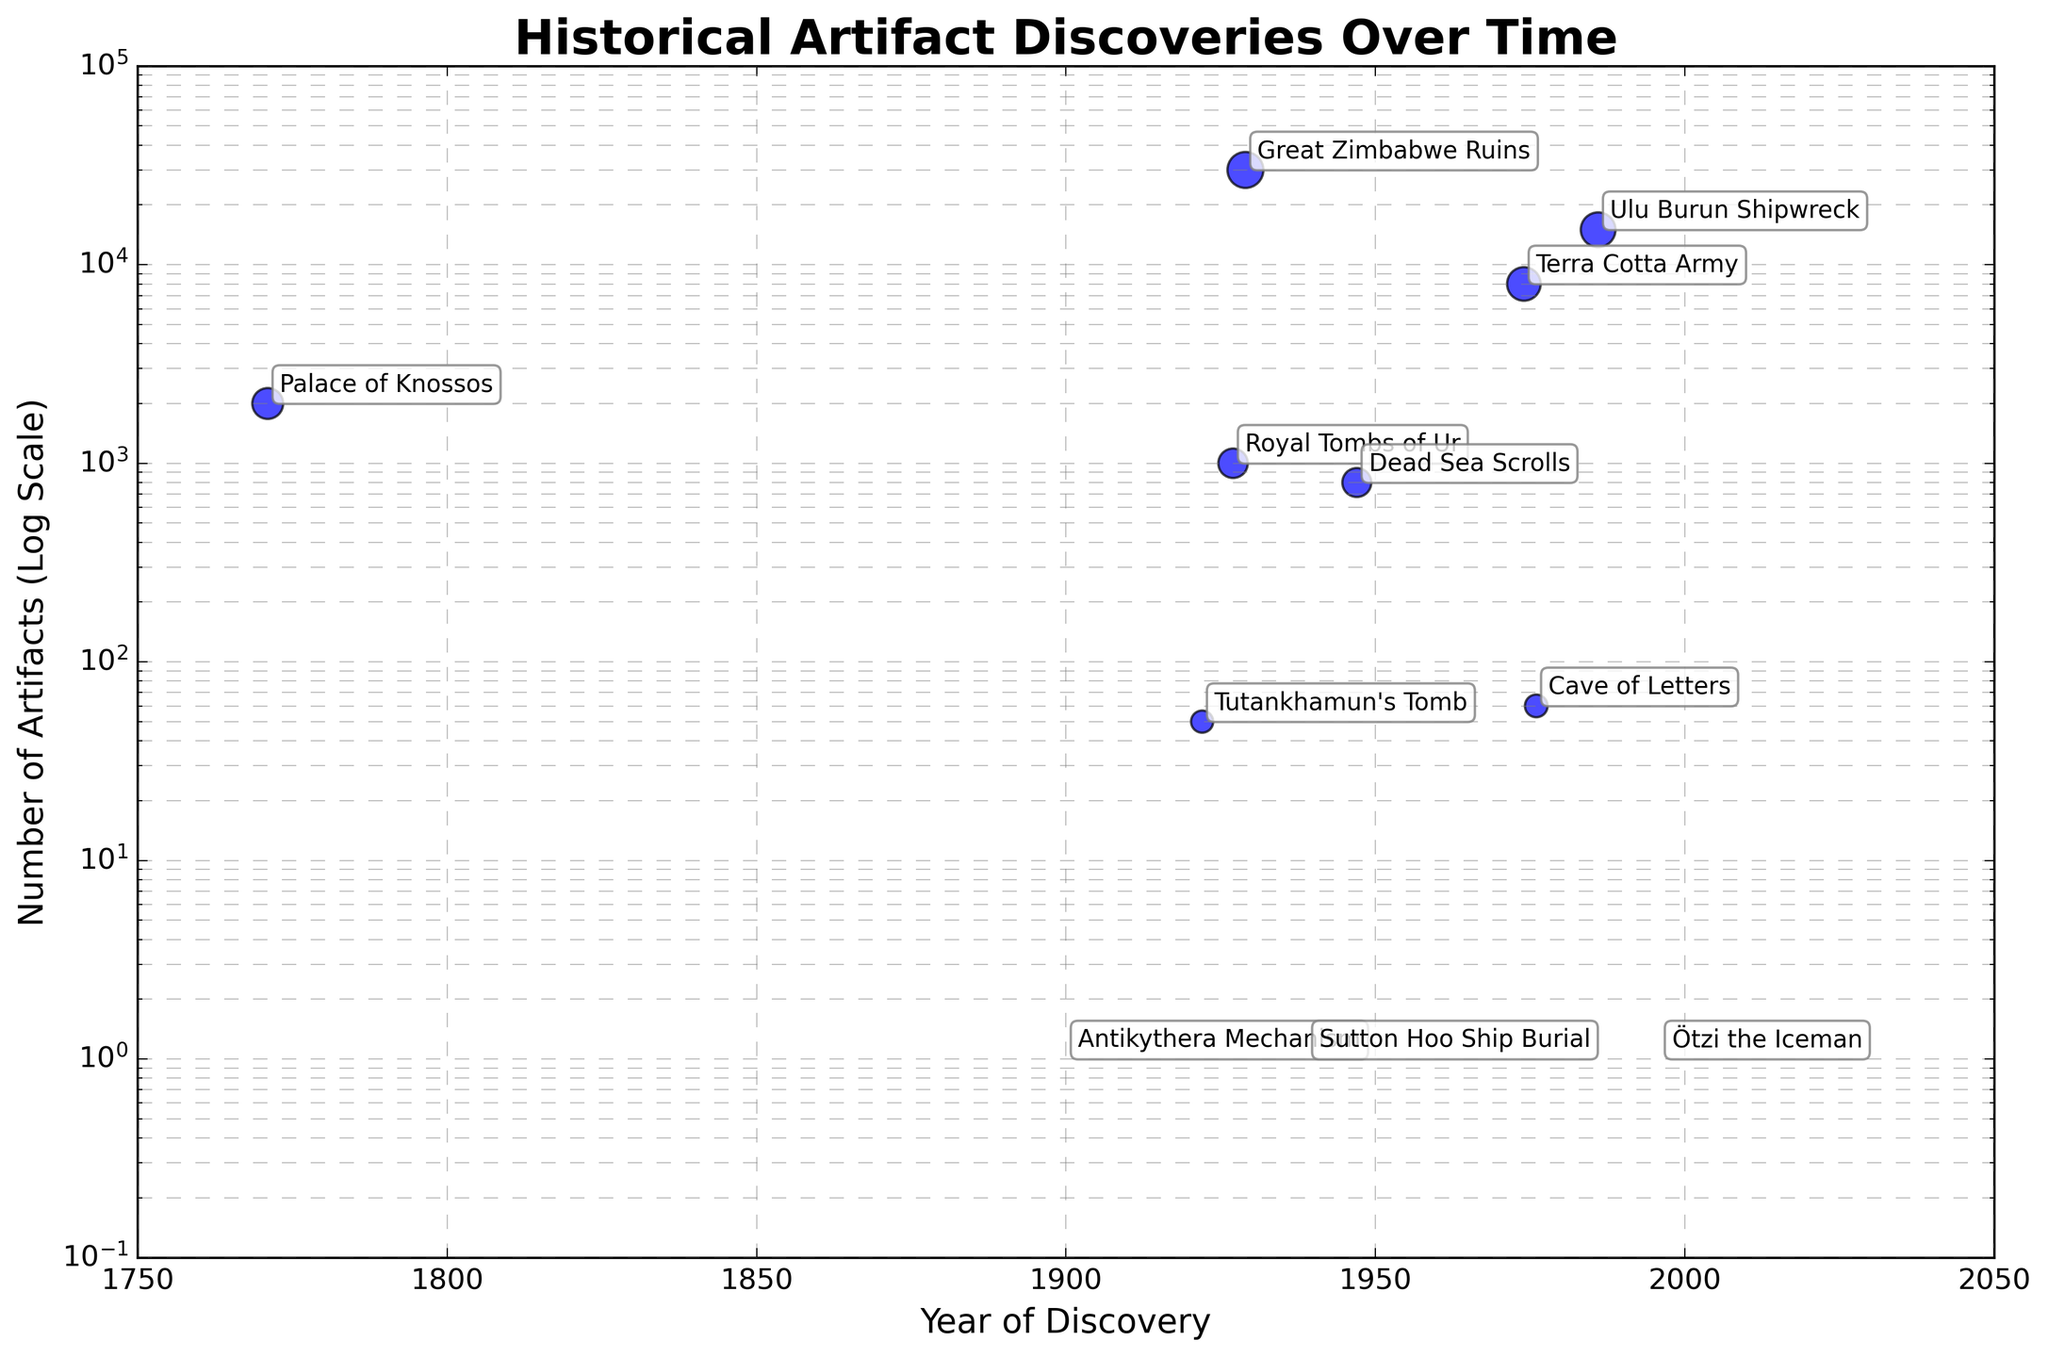What is the title of this plot? The title of the plot is located at the top of the figure and usually summarizes the main idea of the data presented. It's "Historical Artifact Discoveries Over Time".
Answer: Historical Artifact Discoveries Over Time Which discovery has the highest number of artifacts? To determine the discovery with the highest number of artifacts, identify the point with the highest y-axis value. This is the Great Zimbabwe Ruins with 30,000 artifacts.
Answer: Great Zimbabwe Ruins Which year had the lowest number of artifacts discovered, and what was it? The point with the lowest y-axis value represents the discovery with the least number of artifacts. This is the Sutton Hoo Ship Burial in 1939 with 1 artifact.
Answer: 1939, 1 artifact How many discoveries were made before the year 1950? Count the number of points that have x-axis (year) values less than 1950. There are 7 discoveries: 1771 (Palace of Knossos), 1900 (Antikythera Mechanism), 1922 (Tutankhamun's Tomb), 1927 (Royal Tombs of Ur), 1929 (Great Zimbabwe Ruins), 1939 (Sutton Hoo Ship Burial), and 1947 (Dead Sea Scrolls).
Answer: 7 What is the range of years covered by these discoveries? To find the range, subtract the earliest year of discovery from the latest. This is 1996 (Ötzi the Iceman) minus 1771 (Palace of Knossos), which is 225 years.
Answer: 225 years Between which two discoveries was the largest number of artifacts found? Identify which two discoveries have the largest y-axis values and then compare them. These are the Ulu Burun Shipwreck (15,000 artifacts) and the Great Zimbabwe Ruins (30,000 artifacts). The Great Zimbabwe Ruins has more artifacts than the Ulu Burun Shipwreck.
Answer: Great Zimbabwe Ruins and Ulu Burun Shipwreck In what year was the Antikythera Mechanism discovered, and how does its number of artifacts compare to other discoveries in that year? The Antikythera Mechanism was discovered in the year 1900. Its number of artifacts, which is 1, is unique among discoveries because no other artifacts were found in the same year in the dataset.
Answer: 1900, unique with 1 artifact How is the number of artifacts in the Terra Cotta Army compared to the artifacts found in Tutankhamun's Tomb? Compare the y-axis values of the Terra Cotta Army (8,000 artifacts) and Tutankhamun's Tomb (50 artifacts). The Terra Cotta Army has significantly more artifacts than Tutankhamun's Tomb.
Answer: Terra Cotta Army has more What is the median number of artifacts for the discoveries listed? To find the median, list the number of artifacts in ascending order: 1, 1, 1, 50, 60, 800, 1000, 2000, 8000, 15000, 30000. The middle value, or median, of this sorted list is 800 artifacts.
Answer: 800 artifacts Which discovery is closest in time to the discovery of the Dead Sea Scrolls? Identify the year of the Dead Sea Scrolls (1947) and then find the closest neighboring years: Tutankhamun's Tomb (1922) and Cave of Letters (1976). The Cave of Letters, discovered in 1976, is closer in time with a difference of 29 years, compared to 25 years in Tutankhamun's Tomb.
Answer: Tutankhamun’s Tomb, 1922 